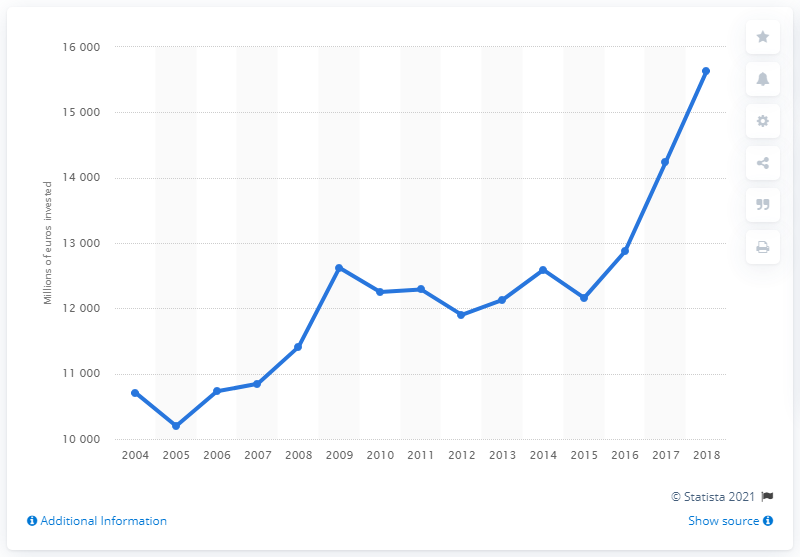Indicate a few pertinent items in this graphic. In 2005, the amount of investment in road transport infrastructure was the lowest at 10,200. In 2018, a total of 15,630 million euros was invested in road transport infrastructure in Germany. 